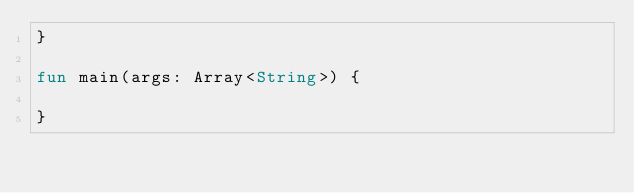Convert code to text. <code><loc_0><loc_0><loc_500><loc_500><_Kotlin_>}

fun main(args: Array<String>) {

}</code> 